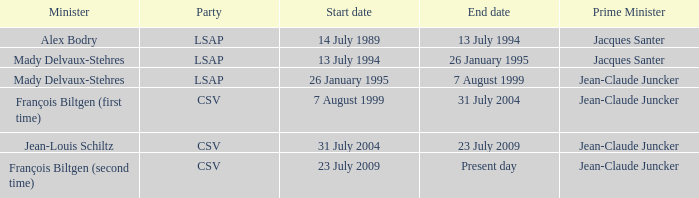Who was the minister representing the csv party with a current day end date? François Biltgen (second time). 